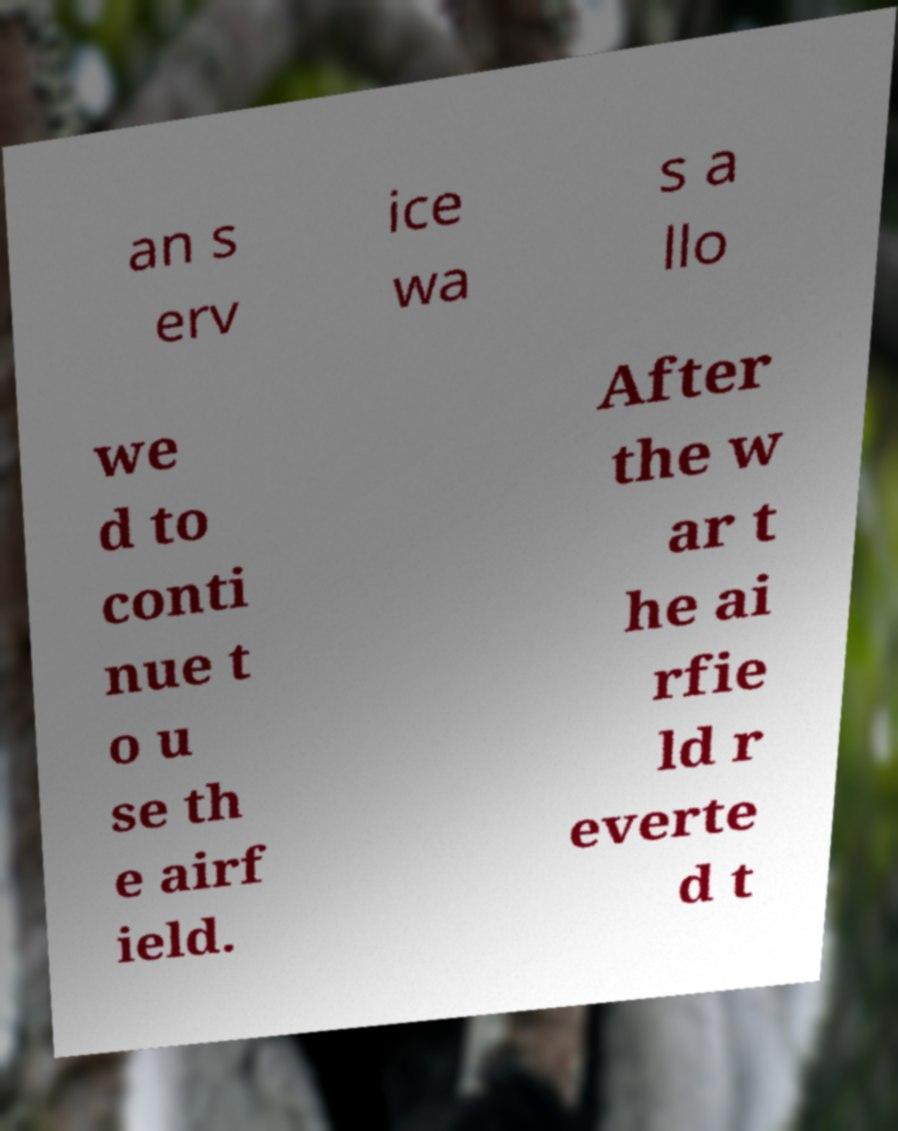I need the written content from this picture converted into text. Can you do that? an s erv ice wa s a llo we d to conti nue t o u se th e airf ield. After the w ar t he ai rfie ld r everte d t 